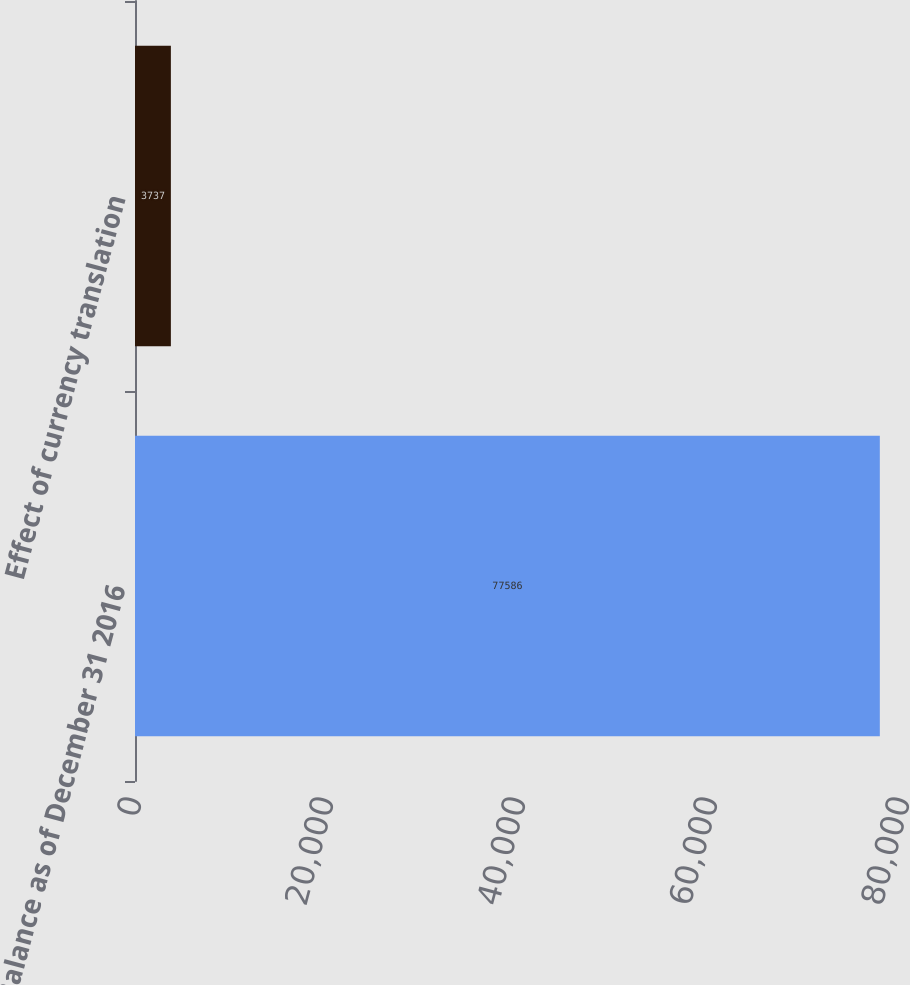Convert chart. <chart><loc_0><loc_0><loc_500><loc_500><bar_chart><fcel>Balance as of December 31 2016<fcel>Effect of currency translation<nl><fcel>77586<fcel>3737<nl></chart> 